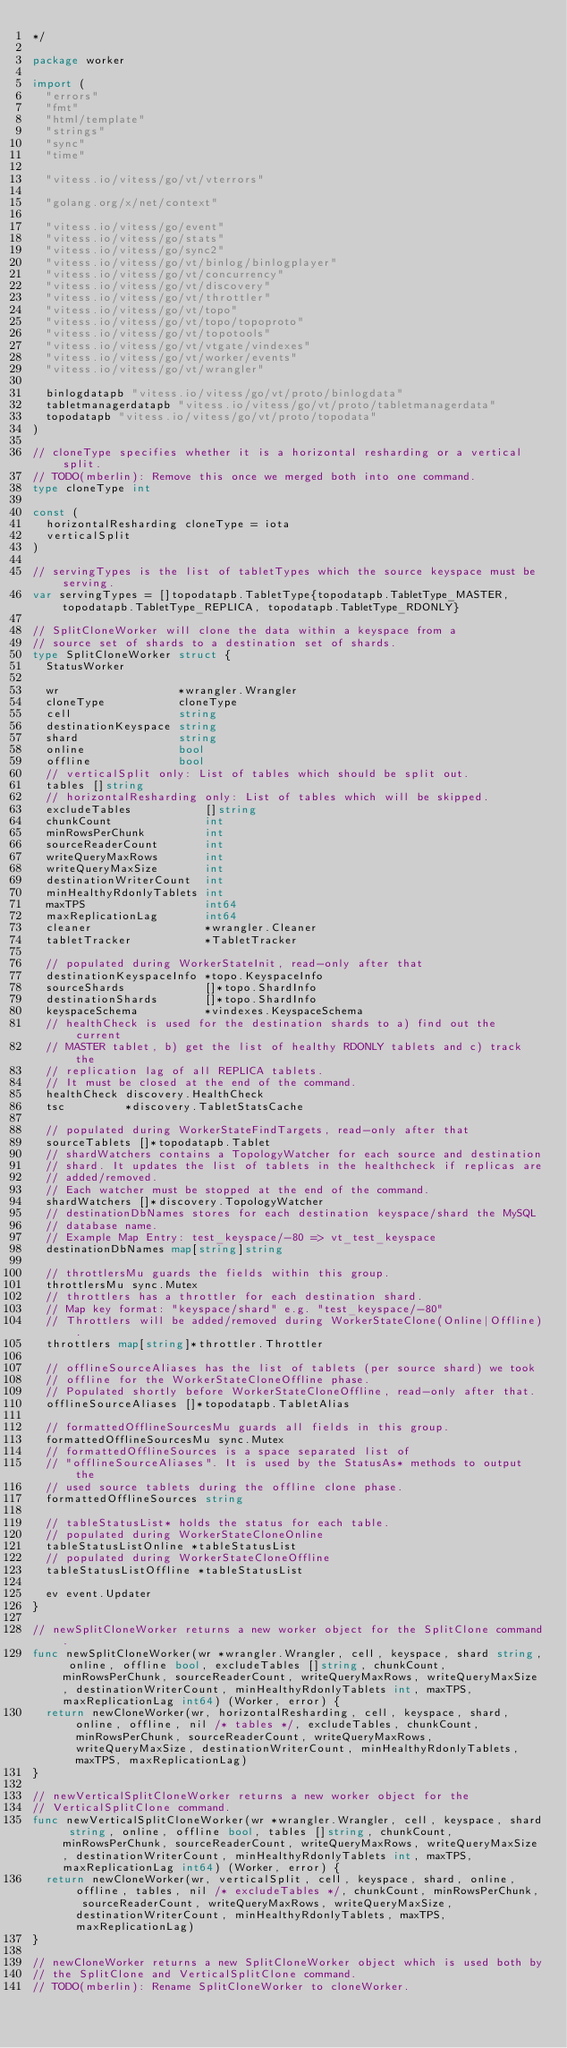Convert code to text. <code><loc_0><loc_0><loc_500><loc_500><_Go_>*/

package worker

import (
	"errors"
	"fmt"
	"html/template"
	"strings"
	"sync"
	"time"

	"vitess.io/vitess/go/vt/vterrors"

	"golang.org/x/net/context"

	"vitess.io/vitess/go/event"
	"vitess.io/vitess/go/stats"
	"vitess.io/vitess/go/sync2"
	"vitess.io/vitess/go/vt/binlog/binlogplayer"
	"vitess.io/vitess/go/vt/concurrency"
	"vitess.io/vitess/go/vt/discovery"
	"vitess.io/vitess/go/vt/throttler"
	"vitess.io/vitess/go/vt/topo"
	"vitess.io/vitess/go/vt/topo/topoproto"
	"vitess.io/vitess/go/vt/topotools"
	"vitess.io/vitess/go/vt/vtgate/vindexes"
	"vitess.io/vitess/go/vt/worker/events"
	"vitess.io/vitess/go/vt/wrangler"

	binlogdatapb "vitess.io/vitess/go/vt/proto/binlogdata"
	tabletmanagerdatapb "vitess.io/vitess/go/vt/proto/tabletmanagerdata"
	topodatapb "vitess.io/vitess/go/vt/proto/topodata"
)

// cloneType specifies whether it is a horizontal resharding or a vertical split.
// TODO(mberlin): Remove this once we merged both into one command.
type cloneType int

const (
	horizontalResharding cloneType = iota
	verticalSplit
)

// servingTypes is the list of tabletTypes which the source keyspace must be serving.
var servingTypes = []topodatapb.TabletType{topodatapb.TabletType_MASTER, topodatapb.TabletType_REPLICA, topodatapb.TabletType_RDONLY}

// SplitCloneWorker will clone the data within a keyspace from a
// source set of shards to a destination set of shards.
type SplitCloneWorker struct {
	StatusWorker

	wr                  *wrangler.Wrangler
	cloneType           cloneType
	cell                string
	destinationKeyspace string
	shard               string
	online              bool
	offline             bool
	// verticalSplit only: List of tables which should be split out.
	tables []string
	// horizontalResharding only: List of tables which will be skipped.
	excludeTables           []string
	chunkCount              int
	minRowsPerChunk         int
	sourceReaderCount       int
	writeQueryMaxRows       int
	writeQueryMaxSize       int
	destinationWriterCount  int
	minHealthyRdonlyTablets int
	maxTPS                  int64
	maxReplicationLag       int64
	cleaner                 *wrangler.Cleaner
	tabletTracker           *TabletTracker

	// populated during WorkerStateInit, read-only after that
	destinationKeyspaceInfo *topo.KeyspaceInfo
	sourceShards            []*topo.ShardInfo
	destinationShards       []*topo.ShardInfo
	keyspaceSchema          *vindexes.KeyspaceSchema
	// healthCheck is used for the destination shards to a) find out the current
	// MASTER tablet, b) get the list of healthy RDONLY tablets and c) track the
	// replication lag of all REPLICA tablets.
	// It must be closed at the end of the command.
	healthCheck discovery.HealthCheck
	tsc         *discovery.TabletStatsCache

	// populated during WorkerStateFindTargets, read-only after that
	sourceTablets []*topodatapb.Tablet
	// shardWatchers contains a TopologyWatcher for each source and destination
	// shard. It updates the list of tablets in the healthcheck if replicas are
	// added/removed.
	// Each watcher must be stopped at the end of the command.
	shardWatchers []*discovery.TopologyWatcher
	// destinationDbNames stores for each destination keyspace/shard the MySQL
	// database name.
	// Example Map Entry: test_keyspace/-80 => vt_test_keyspace
	destinationDbNames map[string]string

	// throttlersMu guards the fields within this group.
	throttlersMu sync.Mutex
	// throttlers has a throttler for each destination shard.
	// Map key format: "keyspace/shard" e.g. "test_keyspace/-80"
	// Throttlers will be added/removed during WorkerStateClone(Online|Offline).
	throttlers map[string]*throttler.Throttler

	// offlineSourceAliases has the list of tablets (per source shard) we took
	// offline for the WorkerStateCloneOffline phase.
	// Populated shortly before WorkerStateCloneOffline, read-only after that.
	offlineSourceAliases []*topodatapb.TabletAlias

	// formattedOfflineSourcesMu guards all fields in this group.
	formattedOfflineSourcesMu sync.Mutex
	// formattedOfflineSources is a space separated list of
	// "offlineSourceAliases". It is used by the StatusAs* methods to output the
	// used source tablets during the offline clone phase.
	formattedOfflineSources string

	// tableStatusList* holds the status for each table.
	// populated during WorkerStateCloneOnline
	tableStatusListOnline *tableStatusList
	// populated during WorkerStateCloneOffline
	tableStatusListOffline *tableStatusList

	ev event.Updater
}

// newSplitCloneWorker returns a new worker object for the SplitClone command.
func newSplitCloneWorker(wr *wrangler.Wrangler, cell, keyspace, shard string, online, offline bool, excludeTables []string, chunkCount, minRowsPerChunk, sourceReaderCount, writeQueryMaxRows, writeQueryMaxSize, destinationWriterCount, minHealthyRdonlyTablets int, maxTPS, maxReplicationLag int64) (Worker, error) {
	return newCloneWorker(wr, horizontalResharding, cell, keyspace, shard, online, offline, nil /* tables */, excludeTables, chunkCount, minRowsPerChunk, sourceReaderCount, writeQueryMaxRows, writeQueryMaxSize, destinationWriterCount, minHealthyRdonlyTablets, maxTPS, maxReplicationLag)
}

// newVerticalSplitCloneWorker returns a new worker object for the
// VerticalSplitClone command.
func newVerticalSplitCloneWorker(wr *wrangler.Wrangler, cell, keyspace, shard string, online, offline bool, tables []string, chunkCount, minRowsPerChunk, sourceReaderCount, writeQueryMaxRows, writeQueryMaxSize, destinationWriterCount, minHealthyRdonlyTablets int, maxTPS, maxReplicationLag int64) (Worker, error) {
	return newCloneWorker(wr, verticalSplit, cell, keyspace, shard, online, offline, tables, nil /* excludeTables */, chunkCount, minRowsPerChunk, sourceReaderCount, writeQueryMaxRows, writeQueryMaxSize, destinationWriterCount, minHealthyRdonlyTablets, maxTPS, maxReplicationLag)
}

// newCloneWorker returns a new SplitCloneWorker object which is used both by
// the SplitClone and VerticalSplitClone command.
// TODO(mberlin): Rename SplitCloneWorker to cloneWorker.</code> 